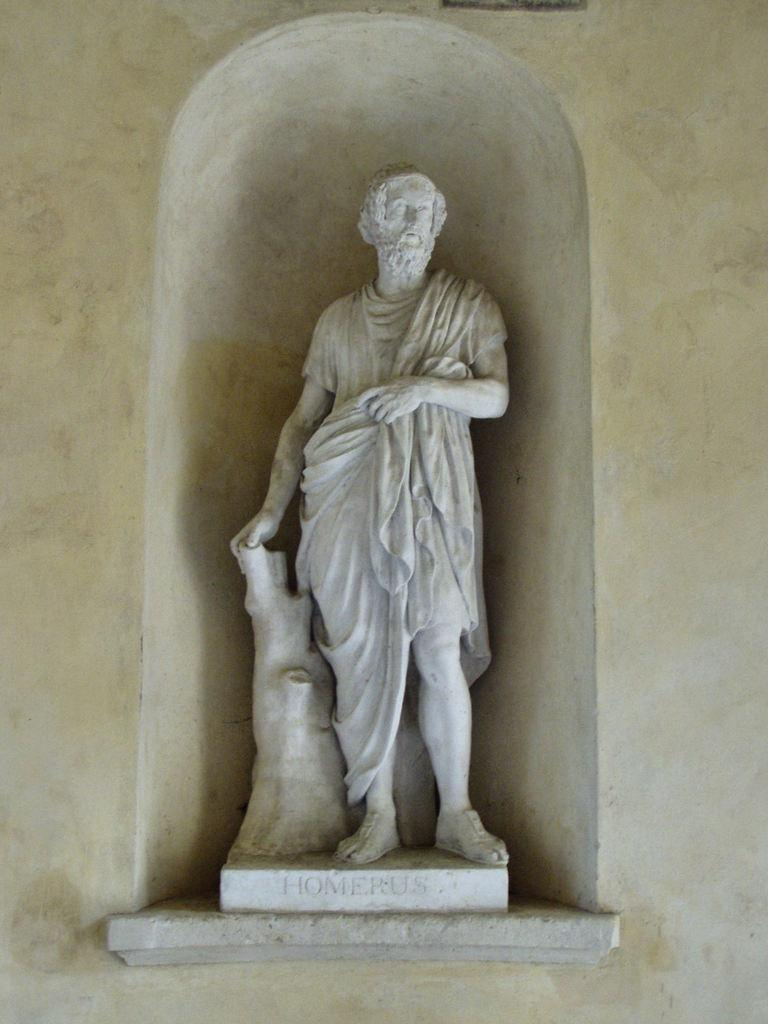What is the main subject of the image? There is a statue of a person in the image. What is written or depicted under the statue? There is text under the statue. What type of background can be seen in the image? There is a wall in the image. How many pies are being carried by the laborer in the image? There is no laborer or pies present in the image; it features a statue of a person and text under it. 